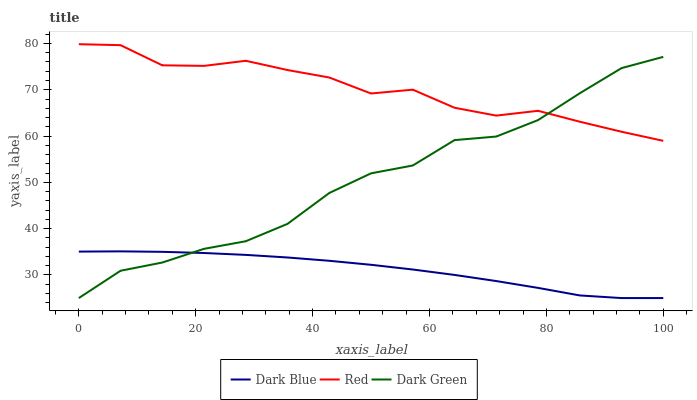Does Dark Blue have the minimum area under the curve?
Answer yes or no. Yes. Does Red have the maximum area under the curve?
Answer yes or no. Yes. Does Dark Green have the minimum area under the curve?
Answer yes or no. No. Does Dark Green have the maximum area under the curve?
Answer yes or no. No. Is Dark Blue the smoothest?
Answer yes or no. Yes. Is Dark Green the roughest?
Answer yes or no. Yes. Is Red the smoothest?
Answer yes or no. No. Is Red the roughest?
Answer yes or no. No. Does Dark Blue have the lowest value?
Answer yes or no. Yes. Does Red have the lowest value?
Answer yes or no. No. Does Red have the highest value?
Answer yes or no. Yes. Does Dark Green have the highest value?
Answer yes or no. No. Is Dark Blue less than Red?
Answer yes or no. Yes. Is Red greater than Dark Blue?
Answer yes or no. Yes. Does Dark Blue intersect Dark Green?
Answer yes or no. Yes. Is Dark Blue less than Dark Green?
Answer yes or no. No. Is Dark Blue greater than Dark Green?
Answer yes or no. No. Does Dark Blue intersect Red?
Answer yes or no. No. 